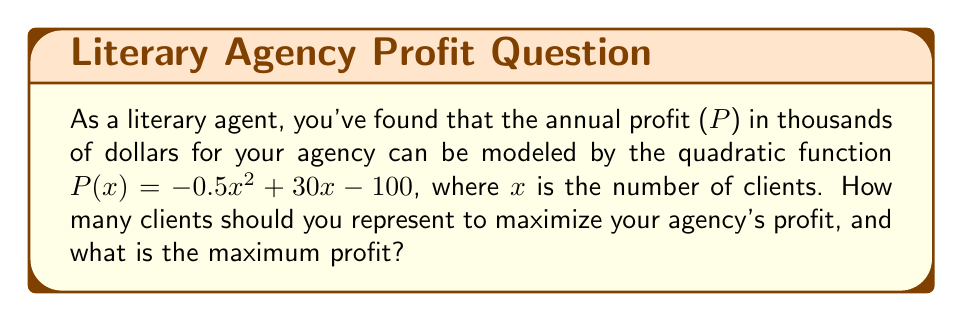Solve this math problem. To solve this problem, we'll follow these steps:

1) The profit function is a quadratic equation in the form $f(x) = ax^2 + bx + c$, where:
   $a = -0.5$, $b = 30$, and $c = -100$

2) For a quadratic function, the maximum or minimum occurs at the vertex. Since $a$ is negative, this parabola opens downward, so the vertex will be the maximum point.

3) To find the x-coordinate of the vertex, we use the formula: $x = -\frac{b}{2a}$

4) Substituting our values:
   $x = -\frac{30}{2(-0.5)} = -\frac{30}{-1} = 30$

5) This means the profit is maximized when the agency has 30 clients.

6) To find the maximum profit, we substitute x = 30 into our original function:

   $P(30) = -0.5(30)^2 + 30(30) - 100$
   $= -0.5(900) + 900 - 100$
   $= -450 + 900 - 100$
   $= 350$

7) Therefore, the maximum profit is $350,000.
Answer: 30 clients; $350,000 